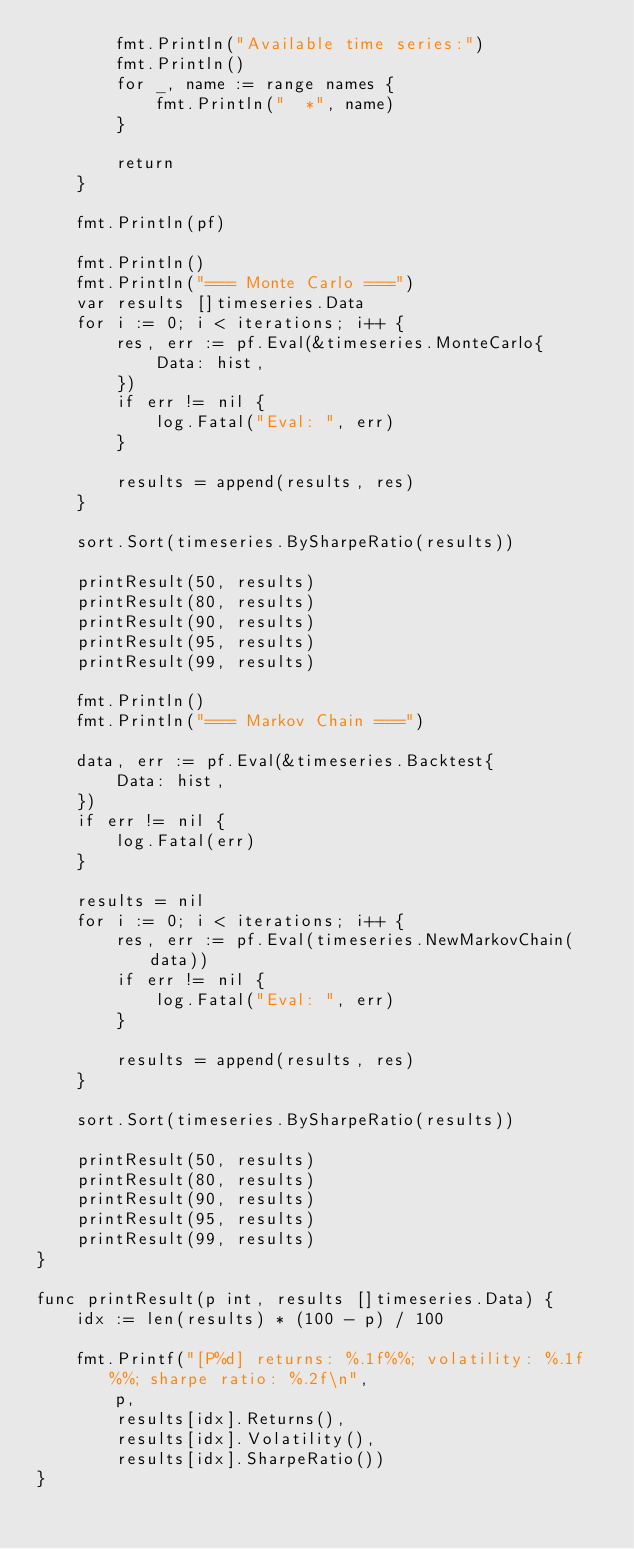Convert code to text. <code><loc_0><loc_0><loc_500><loc_500><_Go_>		fmt.Println("Available time series:")
		fmt.Println()
		for _, name := range names {
			fmt.Println("  *", name)
		}

		return
	}

	fmt.Println(pf)

	fmt.Println()
	fmt.Println("=== Monte Carlo ===")
	var results []timeseries.Data
	for i := 0; i < iterations; i++ {
		res, err := pf.Eval(&timeseries.MonteCarlo{
			Data: hist,
		})
		if err != nil {
			log.Fatal("Eval: ", err)
		}

		results = append(results, res)
	}

	sort.Sort(timeseries.BySharpeRatio(results))

	printResult(50, results)
	printResult(80, results)
	printResult(90, results)
	printResult(95, results)
	printResult(99, results)

	fmt.Println()
	fmt.Println("=== Markov Chain ===")

	data, err := pf.Eval(&timeseries.Backtest{
		Data: hist,
	})
	if err != nil {
		log.Fatal(err)
	}

	results = nil
	for i := 0; i < iterations; i++ {
		res, err := pf.Eval(timeseries.NewMarkovChain(data))
		if err != nil {
			log.Fatal("Eval: ", err)
		}

		results = append(results, res)
	}

	sort.Sort(timeseries.BySharpeRatio(results))

	printResult(50, results)
	printResult(80, results)
	printResult(90, results)
	printResult(95, results)
	printResult(99, results)
}

func printResult(p int, results []timeseries.Data) {
	idx := len(results) * (100 - p) / 100

	fmt.Printf("[P%d] returns: %.1f%%; volatility: %.1f%%; sharpe ratio: %.2f\n",
		p,
		results[idx].Returns(),
		results[idx].Volatility(),
		results[idx].SharpeRatio())
}
</code> 